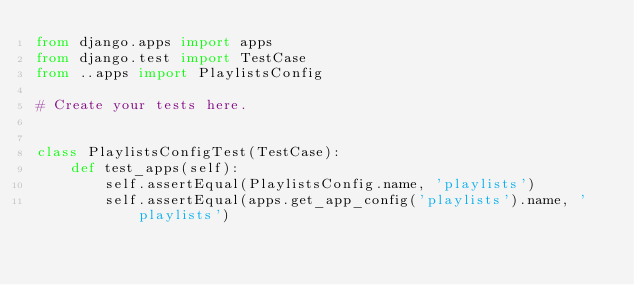Convert code to text. <code><loc_0><loc_0><loc_500><loc_500><_Python_>from django.apps import apps
from django.test import TestCase
from ..apps import PlaylistsConfig

# Create your tests here.


class PlaylistsConfigTest(TestCase):
    def test_apps(self):
        self.assertEqual(PlaylistsConfig.name, 'playlists')
        self.assertEqual(apps.get_app_config('playlists').name, 'playlists')
</code> 